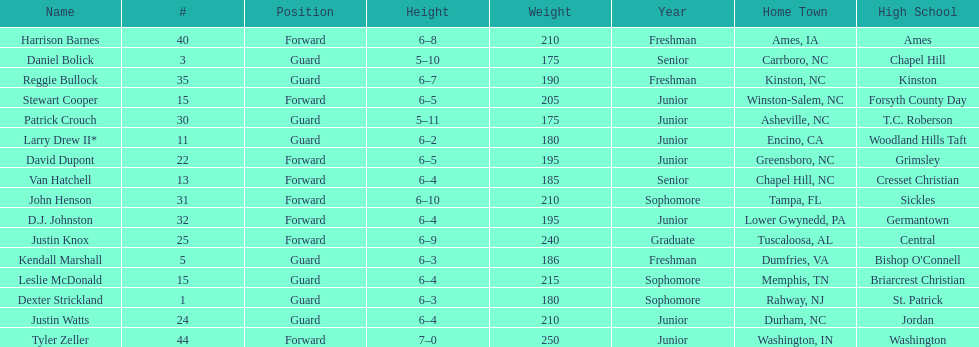Names of players who were exactly 6 feet, 4 inches tall, but did not weight over 200 pounds Van Hatchell, D.J. Johnston. 